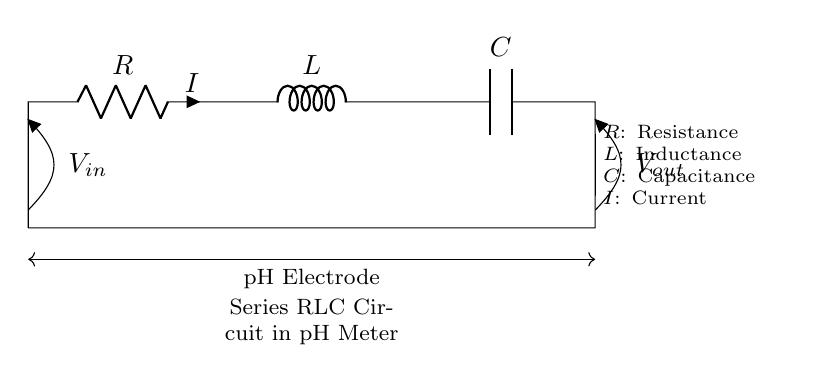What components are present in this circuit? The circuit contains a resistor, inductor, and capacitor connected in series.
Answer: Resistor, inductor, capacitor What type of circuit is illustrated? The circuit is a series RLC circuit, which is characterized by the series connection of a resistor, inductor, and capacitor.
Answer: Series RLC circuit What is the purpose of this circuit in the context provided? This circuit is used in a pH meter for accurate measurements, as the RLC components help to filter and process the signals from the pH electrode.
Answer: pH meter What connects the pH electrode in this circuit? The pH electrode connects the input and output terminals of the circuit, establishing the path for the measurement signals.
Answer: Short How does the voltage 'Vout' relate to 'Vin' in a series RLC circuit? The voltage output 'Vout' is determined by the impedance of the RLC components, which depends on the frequency of the input voltage 'Vin'.
Answer: Frequency-dependent What role does capacitance play in the circuit? Capacitance in the circuit affects the phase shift and resonance behavior, which is crucial for accurate pH measurements in the given application.
Answer: Phase shift, resonance What is the significance of the current 'I' in this circuit? Current 'I' flows through all components in series, and its value is used to analyze the circuit's response and the potential difference across components.
Answer: Flows through all components 